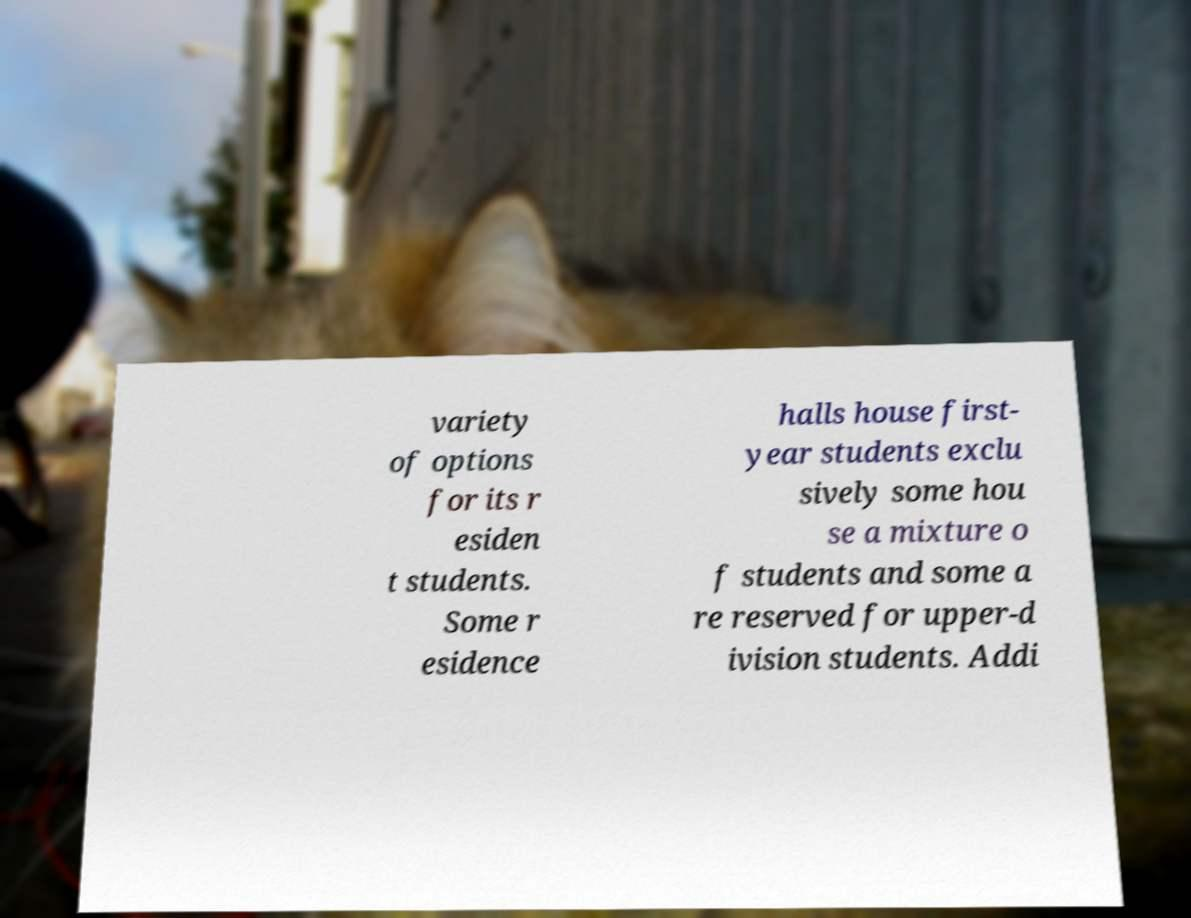What messages or text are displayed in this image? I need them in a readable, typed format. variety of options for its r esiden t students. Some r esidence halls house first- year students exclu sively some hou se a mixture o f students and some a re reserved for upper-d ivision students. Addi 